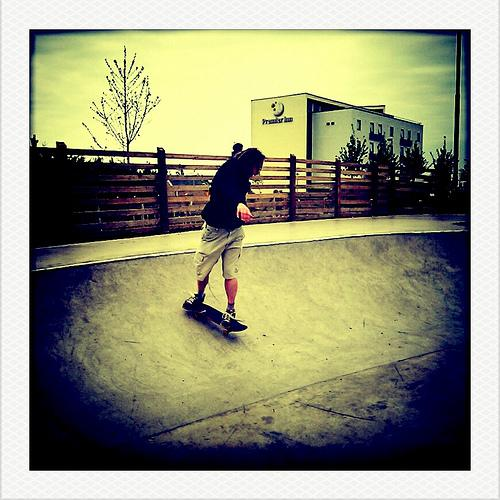What type of shoes does the man have on his feet? The man has black shoes on his feet. What material is the fence made of? The fence is made of wood. What is the man wearing on the lower half of his body? He is wearing tan cargo shorts. How many windows can be seen on the side of the building in the background? There are five windows on the side of the building. What type of ramp the man is skateboarding on? The man is skateboarding on a skate bowl ramp. Describe the background of the image, mentioning the structures and features. There is a wooden fence around the skate park, a tree with no leaves, a building with windows at the top, and an overcast sky in the background. Identify the hand that the man has sticking out of his sleeve. The man has his hand sticking out of the sleeve on his right arm. Identify the primary action of the man in the image. The man is skateboarding on a ramp. What is the color of the fence around the skate park? The fence is brown. Describe the condition of the tree in the background. The tree has no leaves, possibly indicating it is not in its growing season or it is just an empty tree. Create a poem that incorporates the elements in the image. Under an overcast, heavy sky, Identify any text on the top of the building. There are words on the top of the building. What is the primary action of the man in the image? Skateboarding on a ramp In the image, what is the man doing with his hand? The man has one hand sticking out of his sleeve. Determine if the man is wearing a hat. The man is not wearing a hat. Is the man wearing shorts or pants? Shorts Describe the man's outfit in the image in a poetic way. Adorned in a black hoodie, the man sails on his skateboard, clad in tan shorts that dance in the wind. What activity is the man participating in? Skateboarding Create a limerick based on the scene in the image. There once was a skateboarder grand, Can you detect an event taking place in the image? A man skateboarding on a ramp at a skate park Provide a description of the man's clothing while riding the skateboard. The man is wearing a black hoodie jacket, tan cargo shorts, and black shoes. What is the man's emotion as he is skateboarding in the image? The man's emotion is not visible. Describe the fence around the skate park. The fence is wooden, brown, and surrounds the skate park. Which footwear is the man wearing in the image? a) Black shoes b) White shoes c) Brown shoes d) No shoes a) Black shoes Detect the main event of this image. A man is skateboarding in a skate bowl. Write a modern haiku based on the imagery in the photo. Skateboarder takes flight, Describe the architecture of the building behind the fence. The building has windows on its side, with text at the top. Analyze the image and explain the layout of the skate park. The skate park features a ramp with a scuff mark near a wood fence that surrounds the park. A tree and a building with windows can be seen behind the fence. Identify any signs or symbols on the man's skateboard. There are no visible signs or symbols on the skateboard. 